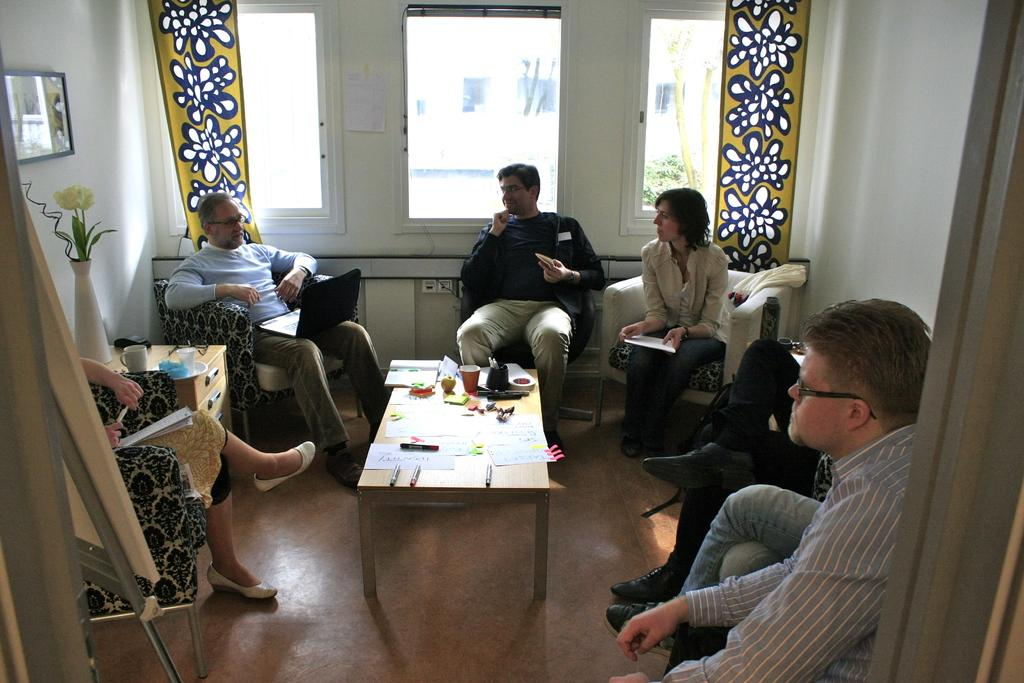What is the main subject of the image? There is a group of people in the image. What are the people doing in the image? The people are seated on chairs. What objects can be seen on the table in the image? There are cups, papers, and pens on the table. Is there any decoration or item on the wall in the image? Yes, there is a photo frame on the wall. What type of mark can be seen on the loaf of bread in the image? There is no loaf of bread present in the image. What is the outcome of the battle depicted in the image? There is no battle depicted in the image. 